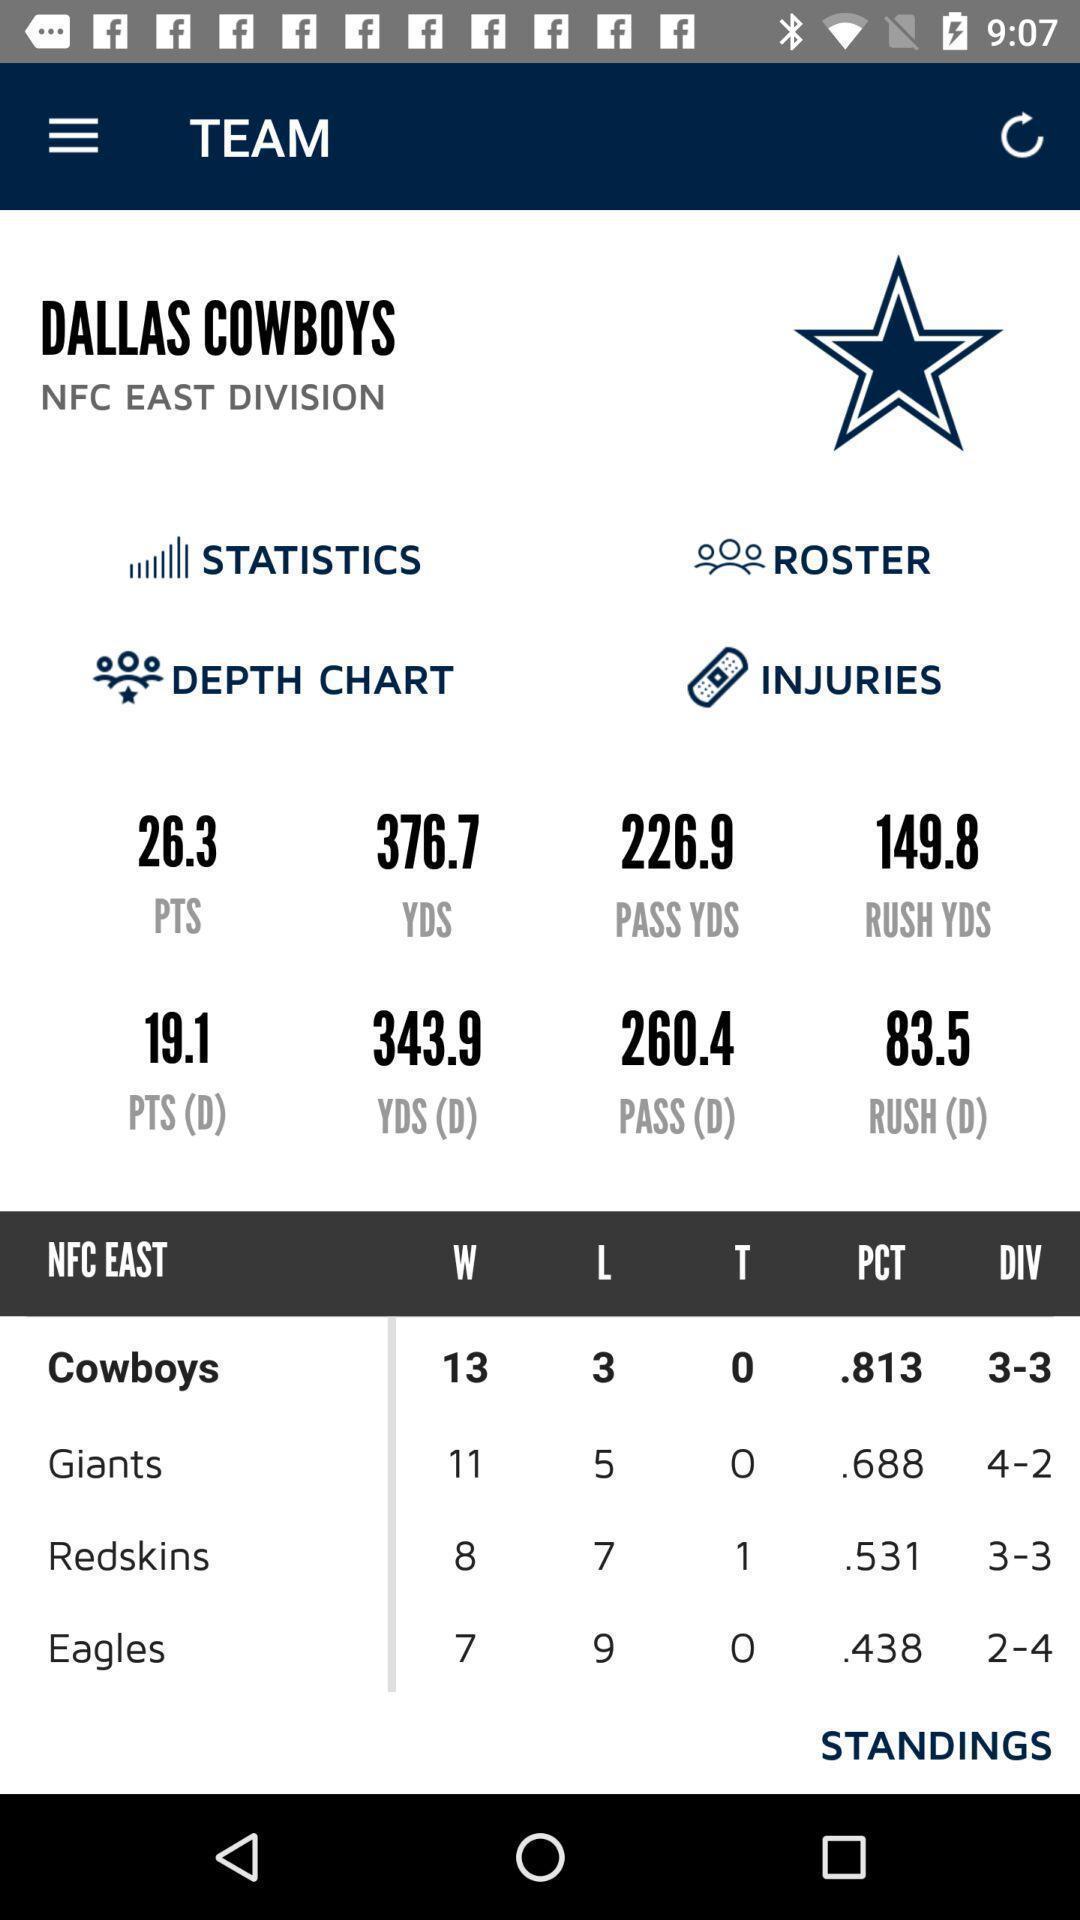Tell me about the visual elements in this screen capture. Screen displaying the team score of a game. 